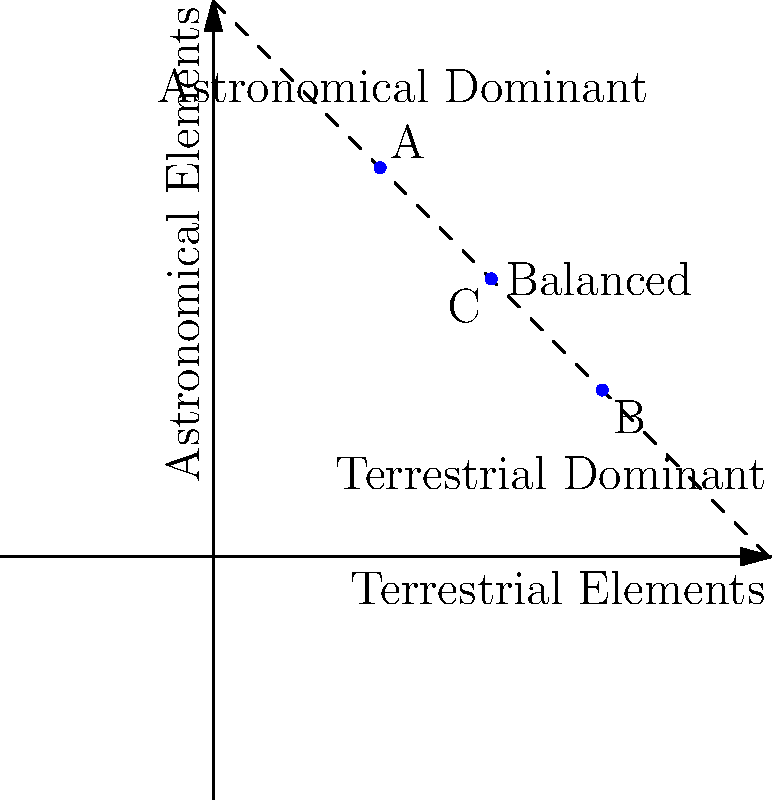In the composition diagram above, which point represents the most balanced integration of terrestrial and astronomical elements according to the Golden Ratio principle often used in astrophotography compositions? To determine the most balanced integration of terrestrial and astronomical elements, we need to consider the Golden Ratio principle, which is often used in astrophotography compositions. The Golden Ratio, approximately 1.618, is considered aesthetically pleasing and balanced.

Step 1: Understand the diagram
- The x-axis represents terrestrial elements
- The y-axis represents astronomical elements
- The dashed line represents perfect balance (1:1 ratio)

Step 2: Analyze the points
A (3,7): More astronomical elements than terrestrial
B (7,3): More terrestrial elements than astronomical
C (5,5): Equal terrestrial and astronomical elements

Step 3: Apply the Golden Ratio principle
In astrophotography, the Golden Ratio is often used to divide the frame between terrestrial and astronomical elements. This would be approximately a 62:38 ratio.

Step 4: Evaluate each point
A (3,7): Ratio is approximately 30:70, too heavily weighted towards astronomical elements
B (7,3): Ratio is approximately 70:30, close to the inverse of the Golden Ratio
C (5,5): Ratio is 50:50, perfectly balanced but not following the Golden Ratio

Step 5: Conclusion
While none of the points exactly match the Golden Ratio, point B (7,3) is the closest approximation. It represents a composition where terrestrial elements slightly dominate, which is often preferred in astrophotography to provide context and grounding for the astronomical elements.
Answer: Point B (7,3) 